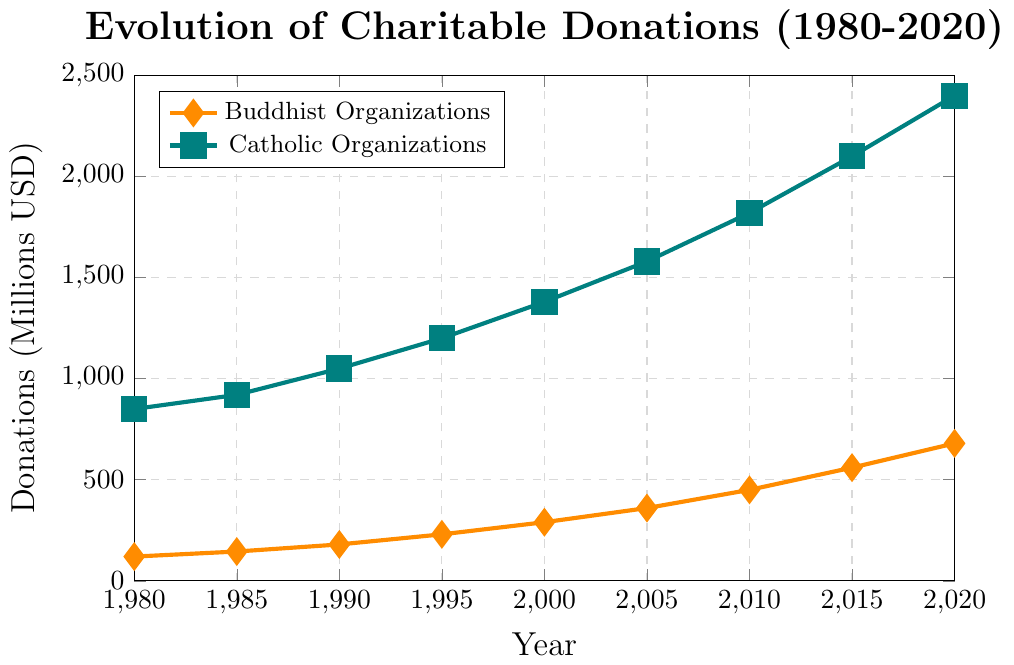What is the trend of charitable donations for Buddhist organizations from 1980 to 2020? The trend for charitable donations to Buddhist organizations shows a steady increase from 1980 to 2020. The donations have grown from 120 million USD in 1980 to 680 million USD in 2020, indicating a rising trend over these four decades.
Answer: Steadily increasing Which organization had higher charitable donations in the year 2000? In the year 2000, Catholic organizations had higher charitable donations compared to Buddhist organizations. As per the figure, Catholic organizations received 1380 million USD, while Buddhist organizations received 290 million USD.
Answer: Catholic organizations By how much did the charitable donations to Catholic organizations increase from 1980 to 2020? Charitable donations to Catholic organizations in 1980 were 850 million USD, and in 2020, they were 2400 million USD. The increase is calculated by subtracting the initial value from the final value: 2400 - 850 = 1550 million USD.
Answer: 1550 million USD What was the difference in charitable donations between Buddhist and Catholic organizations in 1990? In 1990, the charitable donations for Buddhist organizations were 180 million USD, and for Catholic organizations, it was 1050 million USD. The difference is calculated by subtracting the former from the latter: 1050 - 180 = 870 million USD.
Answer: 870 million USD Between which consecutive years did Buddhist organizations see the highest increase in charitable donations? To find the highest increase in charitable donations for Buddhist organizations between consecutive years, we look at the differences between each pair of consecutive years: 
1980-1985: 145 - 120 = 25 
1985-1990: 180 - 145 = 35 
1990-1995: 230 - 180 = 50 
1995-2000: 290 - 230 = 60 
2000-2005: 360 - 290 = 70 
2005-2010: 450 - 360 = 90 
2010-2015: 560 - 450 = 110 
2015-2020: 680 - 560 = 120 
The highest increase is from 2015 to 2020, which is 120 million USD.
Answer: 2015 to 2020 What is the average annual donation for Buddhist organizations between 1980 and 2020? To calculate the average annual donation for Buddhist organizations between 1980 and 2020, first sum the donation values for the given years: 120 + 145 + 180 + 230 + 290 + 360 + 450 + 560 + 680 = 3015 million USD. There are 9 data points, so the average is 3015 / 9 = 335 million USD.
Answer: 335 million USD How do the growth rates of charitable donations compare between Buddhist and Catholic organizations over the 40-year period? To compare the growth rates, calculate the initial and final values for both organizations over the 40-year period. Buddhist organizations grew from 120 million USD in 1980 to 680 million USD in 2020, an increase of 680 - 120 = 560 million USD. Catholic organizations grew from 850 million USD in 1980 to 2400 million USD in 2020, an increase of 2400 - 850 = 1550 million USD. Though Catholic organizations had a higher absolute increase, calculating percentages can offer more insight: 
Buddhist: (560 / 120) * 100 = 466.67% 
Catholic: (1550 / 850) * 100 = 182.35% 
Thus, Buddhist organizations had a higher growth rate compared to Catholic organizations.
Answer: Buddhist organizations had a higher growth rate Which year marks the greatest difference in donations between the two organizations, and what is the difference? Calculating the differences for each year: 
1980: 850 - 120 = 730 
1985: 920 - 145 = 775 
1990: 1050 - 180 = 870 
1995: 1200 - 230 = 970 
2000: 1380 - 290 = 1090 
2005: 1580 - 360 = 1220 
2010: 1820 - 450 = 1370 
2015: 2100 - 560 = 1540 
2020: 2400 - 680 = 1720 
The greatest difference is in the year 2020, with a difference of 1720 million USD.
Answer: 2020, 1720 million USD What visual attributes are used to differentiate data for Buddhist and Catholic organizations in the plot? The plot uses different visual attributes to differentiate the data for Buddhist and Catholic organizations. Buddhist organizations are represented by an orange line with diamond markers, whereas Catholic organizations are depicted using a teal-green line with square markers. The line width and marker sizes are consistent across both categories.
Answer: Color and marker shapes 